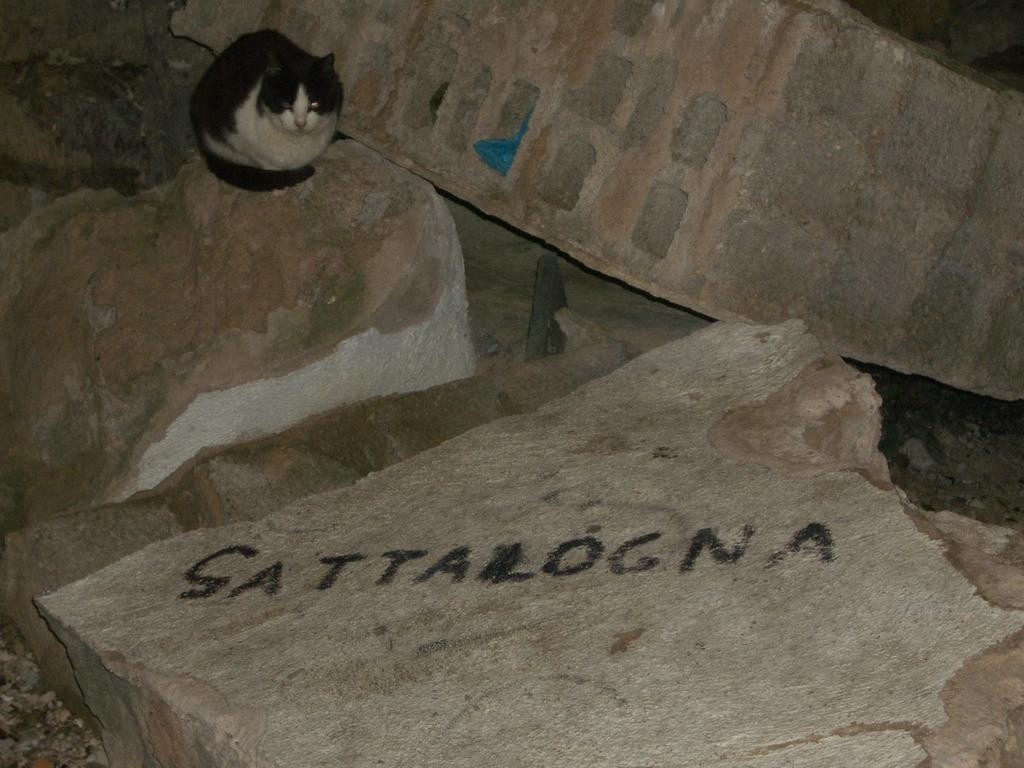What animal is present in the image? There is a cat in the image. Where is the cat located? The cat is on a rock in the image. What else can be seen in the image besides the cat? There are rocks in the image. How many threads are used to tie the birthday balloon in the image? There is no birthday balloon present in the image, so it is not possible to determine how many threads are used to tie it. 